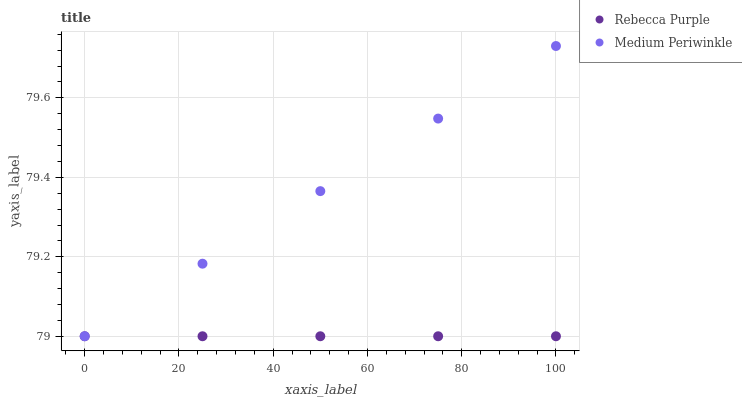Does Rebecca Purple have the minimum area under the curve?
Answer yes or no. Yes. Does Medium Periwinkle have the maximum area under the curve?
Answer yes or no. Yes. Does Rebecca Purple have the maximum area under the curve?
Answer yes or no. No. Is Rebecca Purple the smoothest?
Answer yes or no. Yes. Is Medium Periwinkle the roughest?
Answer yes or no. Yes. Is Rebecca Purple the roughest?
Answer yes or no. No. Does Medium Periwinkle have the lowest value?
Answer yes or no. Yes. Does Medium Periwinkle have the highest value?
Answer yes or no. Yes. Does Rebecca Purple have the highest value?
Answer yes or no. No. Does Medium Periwinkle intersect Rebecca Purple?
Answer yes or no. Yes. Is Medium Periwinkle less than Rebecca Purple?
Answer yes or no. No. Is Medium Periwinkle greater than Rebecca Purple?
Answer yes or no. No. 